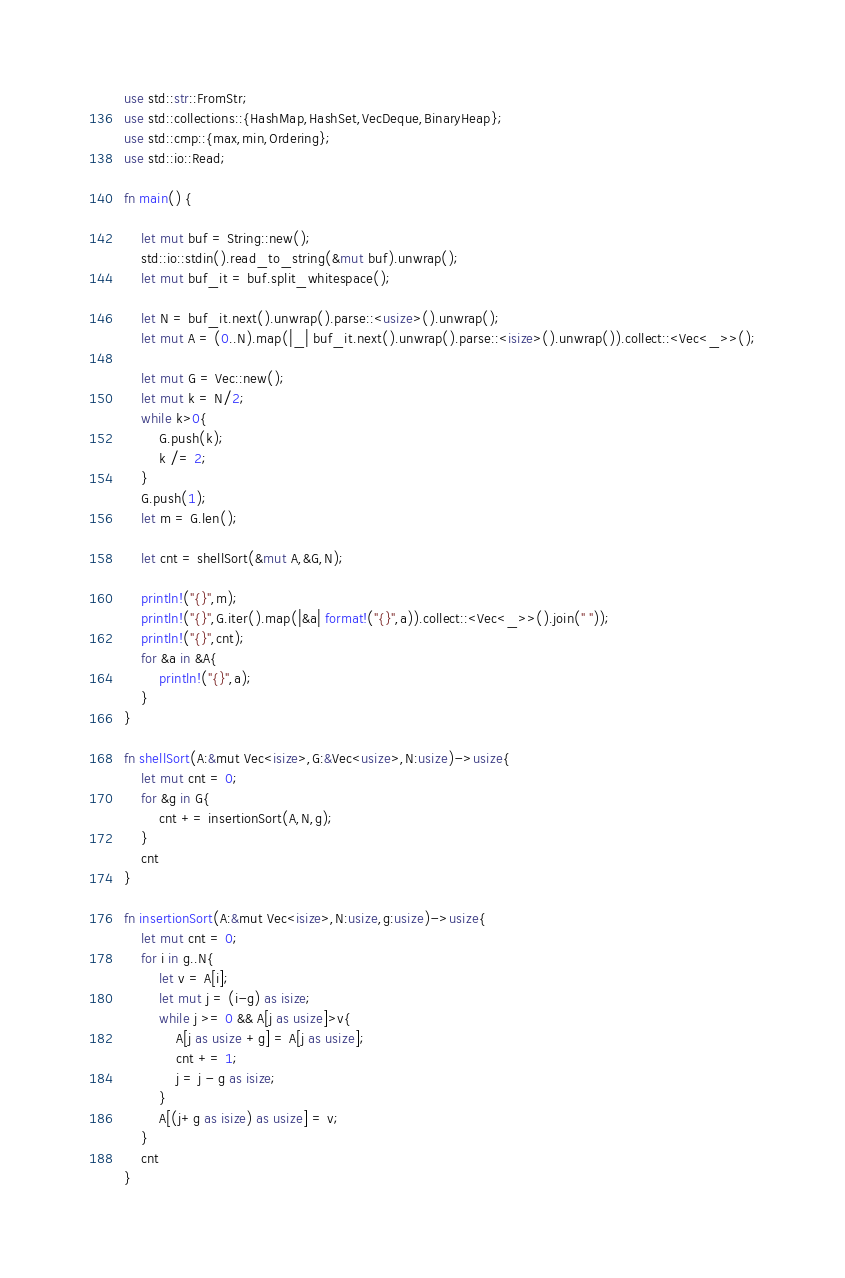Convert code to text. <code><loc_0><loc_0><loc_500><loc_500><_Rust_>use std::str::FromStr;
use std::collections::{HashMap,HashSet,VecDeque,BinaryHeap};
use std::cmp::{max,min,Ordering};
use std::io::Read;

fn main() {

    let mut buf = String::new();
    std::io::stdin().read_to_string(&mut buf).unwrap();
    let mut buf_it = buf.split_whitespace();

    let N = buf_it.next().unwrap().parse::<usize>().unwrap();
    let mut A = (0..N).map(|_| buf_it.next().unwrap().parse::<isize>().unwrap()).collect::<Vec<_>>();

    let mut G = Vec::new();
    let mut k = N/2;
    while k>0{
        G.push(k);
        k /= 2;
    }
    G.push(1);
    let m = G.len();

    let cnt = shellSort(&mut A,&G,N);

    println!("{}",m);
    println!("{}",G.iter().map(|&a| format!("{}",a)).collect::<Vec<_>>().join(" "));
    println!("{}",cnt);
    for &a in &A{
        println!("{}",a);
    }
}

fn shellSort(A:&mut Vec<isize>,G:&Vec<usize>,N:usize)->usize{
    let mut cnt = 0;
    for &g in G{
        cnt += insertionSort(A,N,g);
    }
    cnt
}

fn insertionSort(A:&mut Vec<isize>,N:usize,g:usize)->usize{
    let mut cnt = 0;
    for i in g..N{
        let v = A[i];
        let mut j = (i-g) as isize;
        while j >= 0 && A[j as usize]>v{
            A[j as usize +g] = A[j as usize];
            cnt += 1;
            j = j - g as isize;
        }
        A[(j+g as isize) as usize] = v;
    }
    cnt
}
</code> 